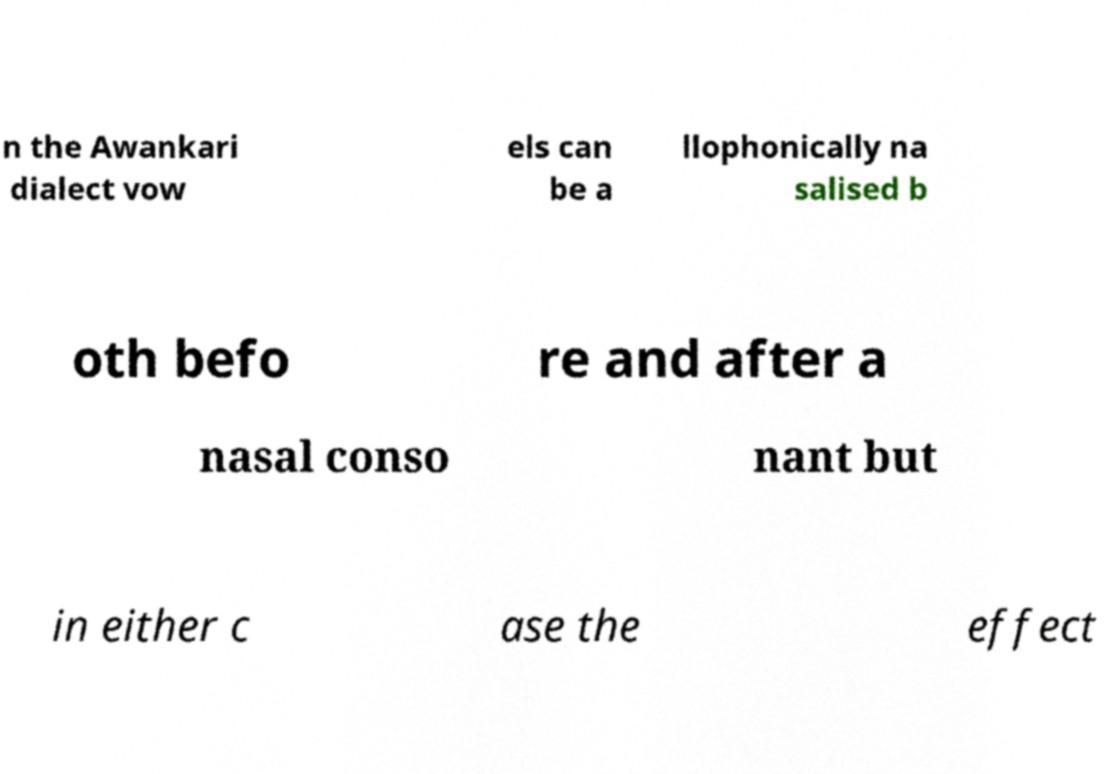Please identify and transcribe the text found in this image. n the Awankari dialect vow els can be a llophonically na salised b oth befo re and after a nasal conso nant but in either c ase the effect 